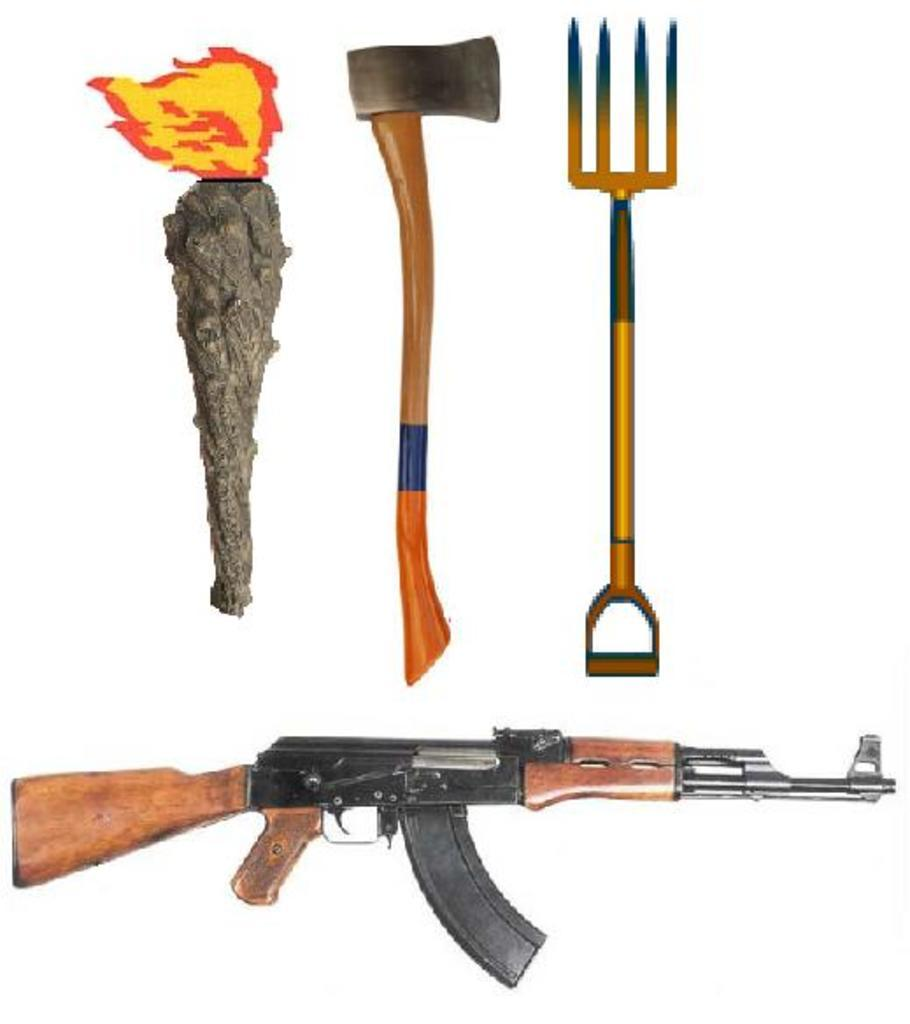What type of weapon is present in the image? There is a gun in the image. What other weapon can be seen in the image? There is an axe in the image. Can you describe any other objects in the image besides the weapons? There are some other unspecified things in the image. What type of grass is growing around the queen's house in the image? There is no queen or house present in the image, and therefore no grass can be observed. 